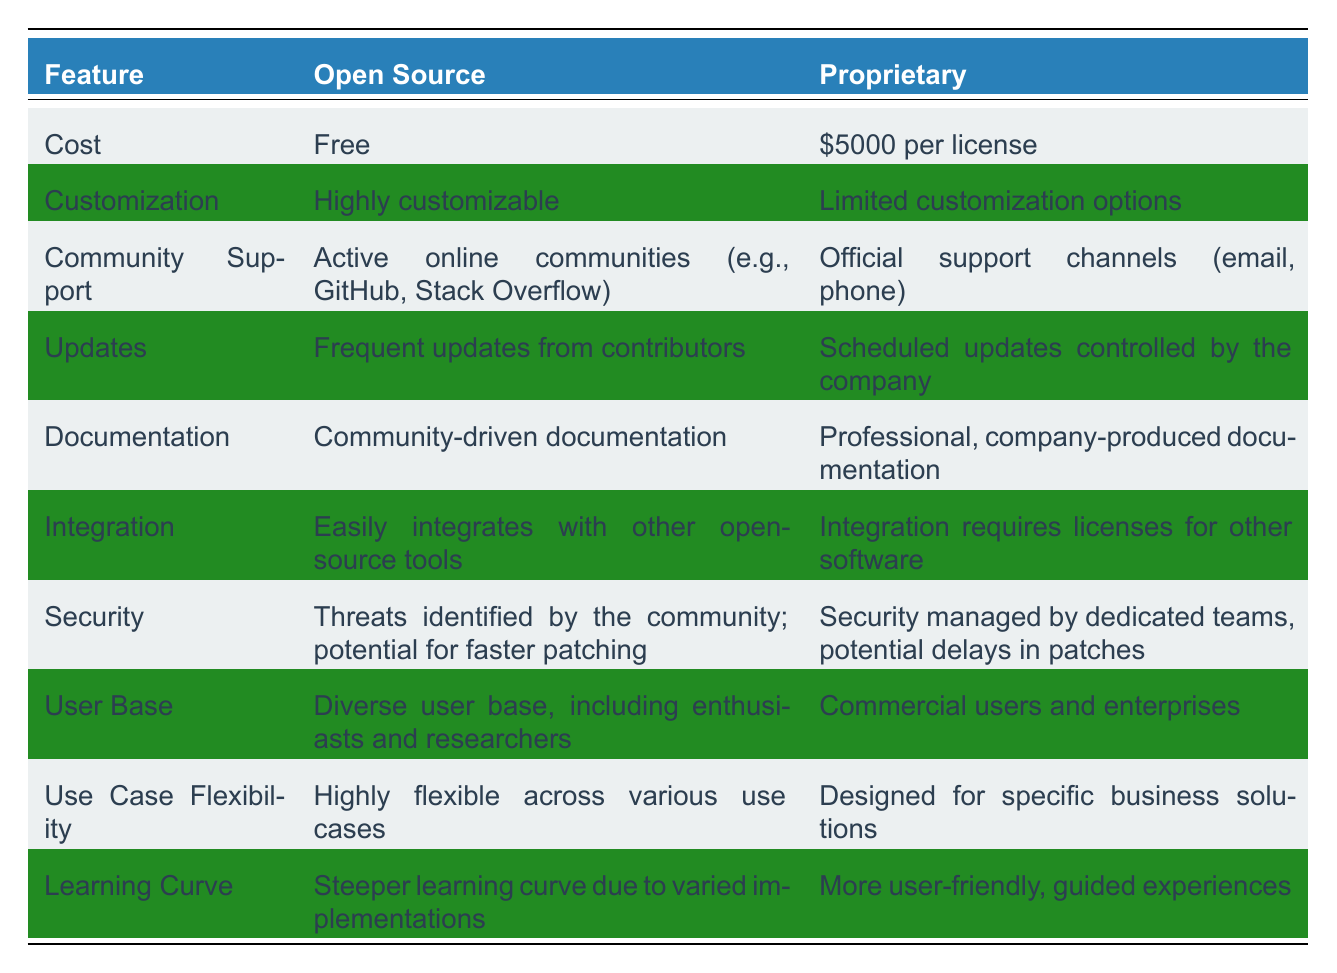What is the cost of Open Source AI solutions? The cost of Open Source AI solutions is listed in the "Cost" row as "Free".
Answer: Free Is the customization of Proprietary AI solutions limited? The table states that Proprietary solutions have "Limited customization options" in the "Customization" row, which confirms that they are indeed limited.
Answer: Yes Which type of AI solution has community-driven documentation? The "Documentation" row shows that Open Source has "Community-driven documentation", while Proprietary has "Professional, company-produced documentation". Therefore, Open Source is the type that has community-driven documentation.
Answer: Open Source What is the average cost difference between Open Source and Proprietary solutions? Open Source is free (0), and Proprietary is $5000, making the cost difference $5000 - 0 = $5000. Thus, the average cost difference is $5000.
Answer: $5000 How do the update frequencies of Open Source and Proprietary solutions compare? The "Updates" row lists Open Source as having "Frequent updates from contributors" and Proprietary as having "Scheduled updates controlled by the company". This indicates that Open Source receives more frequent updates than Proprietary.
Answer: Open Source has more frequent updates Is it true that Open Source solutions integrate easily with other tools? The "Integration" row notes that Open Source "Easily integrates with other open-source tools", confirming that this statement is true.
Answer: Yes Which AI solution caters to a more diverse user base? Referring to the "User Base" row, Open Source has "Diverse user base, including enthusiasts and researchers", while Proprietary is for "Commercial users and enterprises". Thus, Open Source caters to a more diverse user base.
Answer: Open Source Does the learning curve for Proprietary solutions tend to be steeper? According to the "Learning Curve" row, Open Source has a "Steeper learning curve due to varied implementations", while Proprietary is described as "More user-friendly, guided experiences". This means Proprietary solutions are less steep.
Answer: No How flexible are Open Source solutions across various use cases? The "Use Case Flexibility" row indicates that Open Source is "Highly flexible across various use cases", confirming that Open Source solutions are indeed very flexible.
Answer: Highly flexible What are the potential drawbacks of Proprietary AI solutions? The table highlights several limitations for Proprietary solutions, including limited customization options, scheduled updates, and a more user-friendly setup which might not cater well to varied needs. These factors can be considered as potential drawbacks.
Answer: Limited customization, scheduled updates, and lack of flexibility 